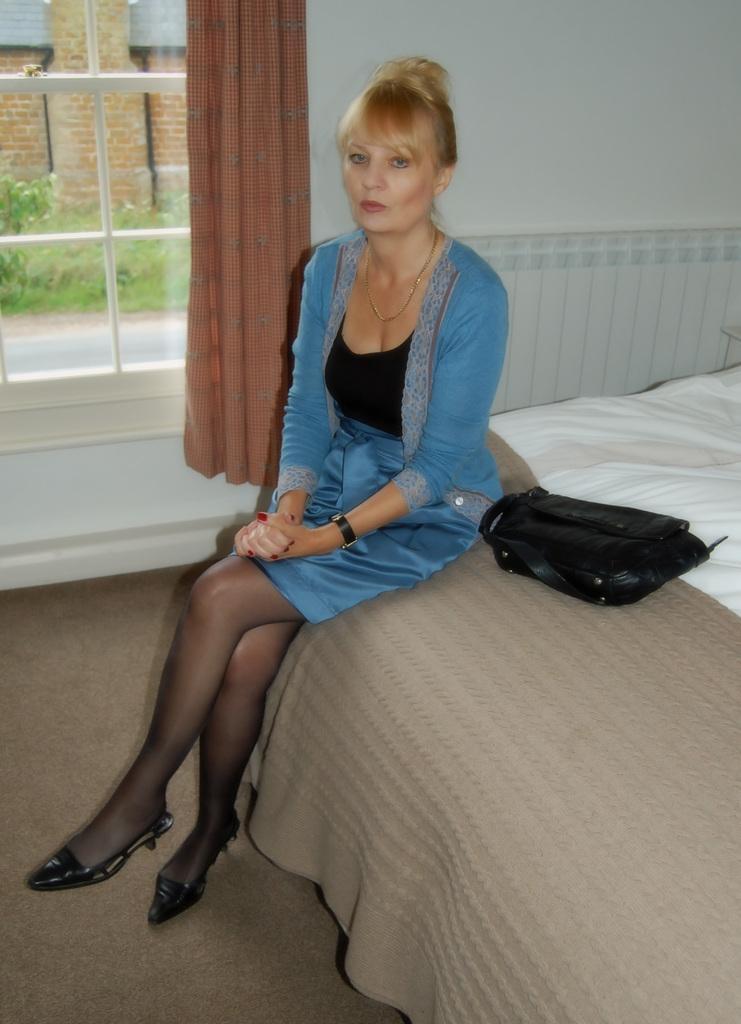Could you give a brief overview of what you see in this image? The picture is taken in a closed room where one woman wearing a blue dress and shoes is sitting on the bed and beside her there is a bag and behind her there is a window with curtain and outside of the window there are some plants and building. 